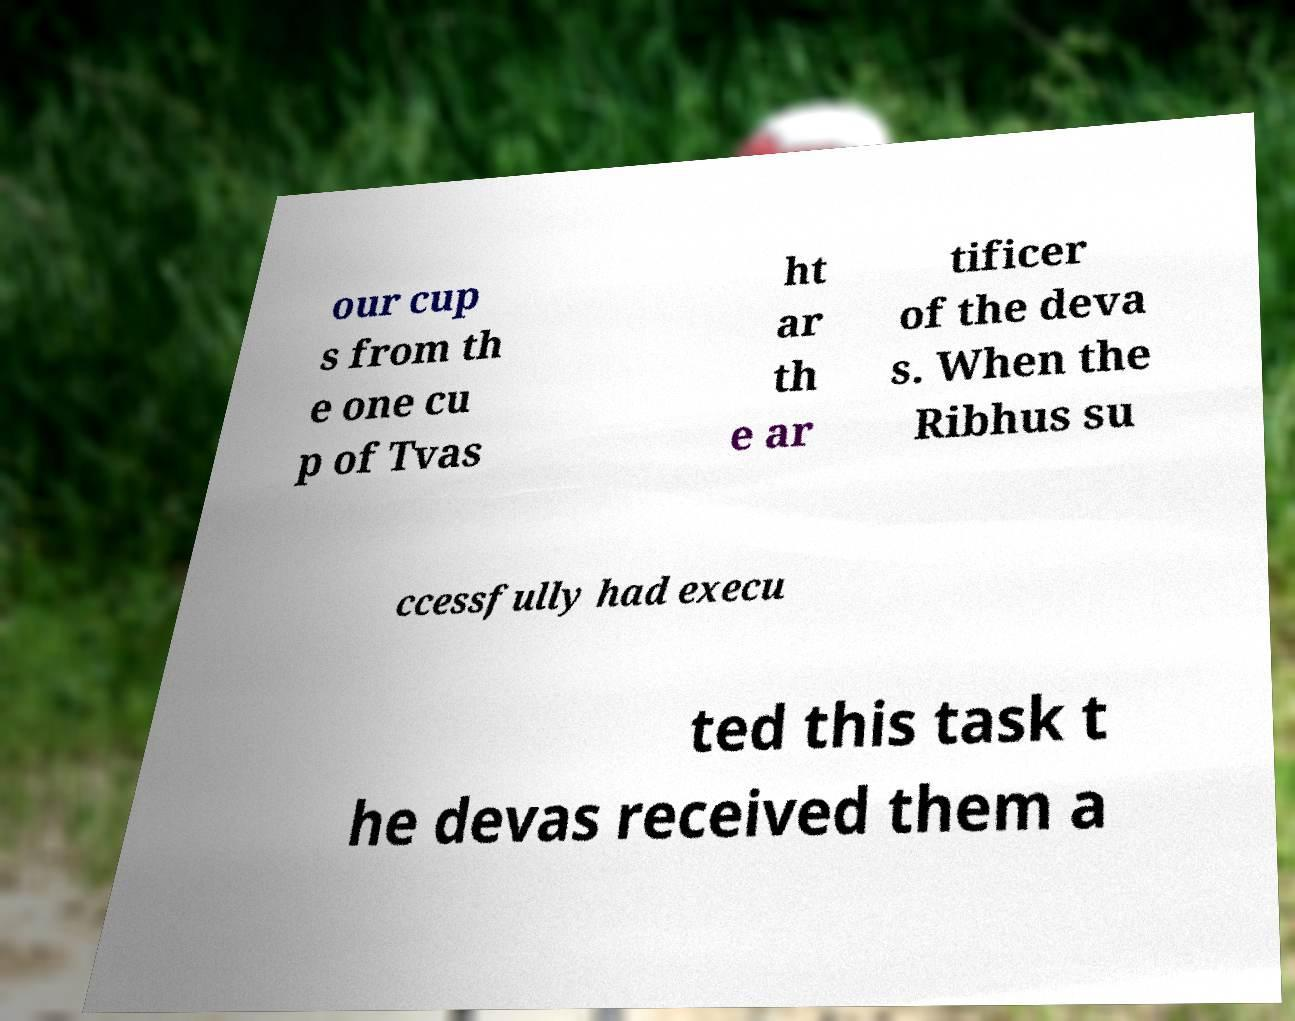Please identify and transcribe the text found in this image. our cup s from th e one cu p of Tvas ht ar th e ar tificer of the deva s. When the Ribhus su ccessfully had execu ted this task t he devas received them a 